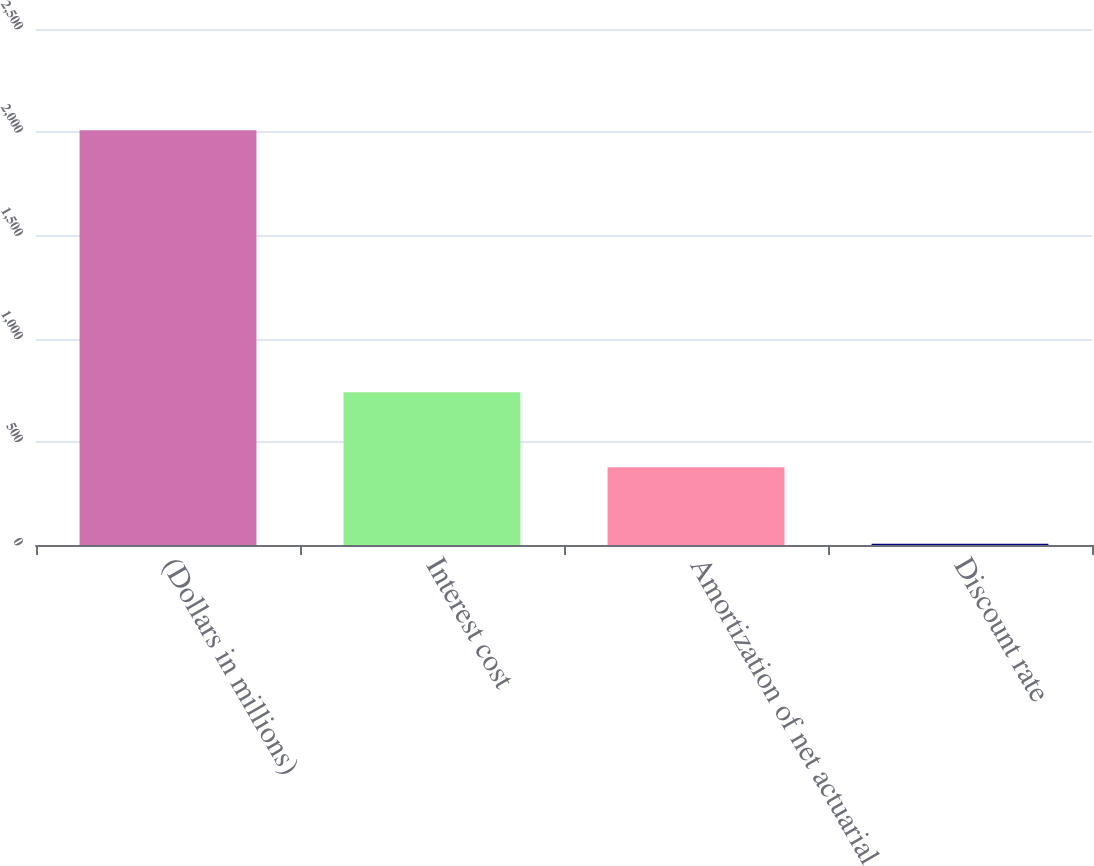Convert chart. <chart><loc_0><loc_0><loc_500><loc_500><bar_chart><fcel>(Dollars in millions)<fcel>Interest cost<fcel>Amortization of net actuarial<fcel>Discount rate<nl><fcel>2009<fcel>740<fcel>377<fcel>6<nl></chart> 